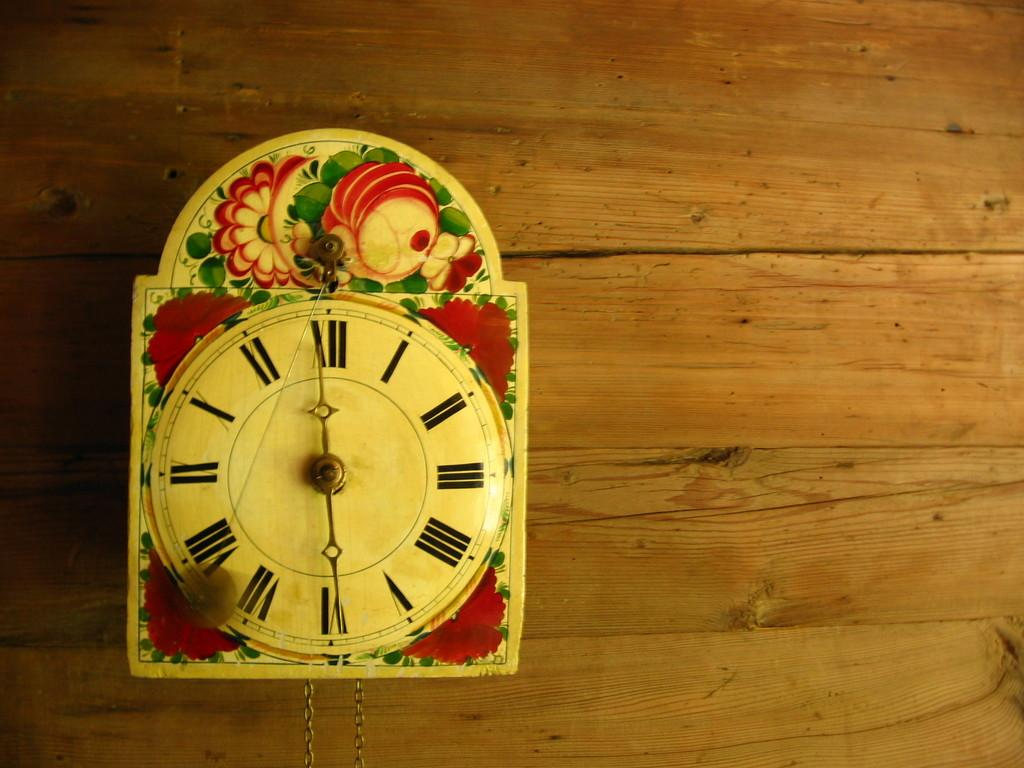<image>
Present a compact description of the photo's key features. A clock adorned with flowers displays the time of 6:00 with roman numerals, such as XII and VI. 